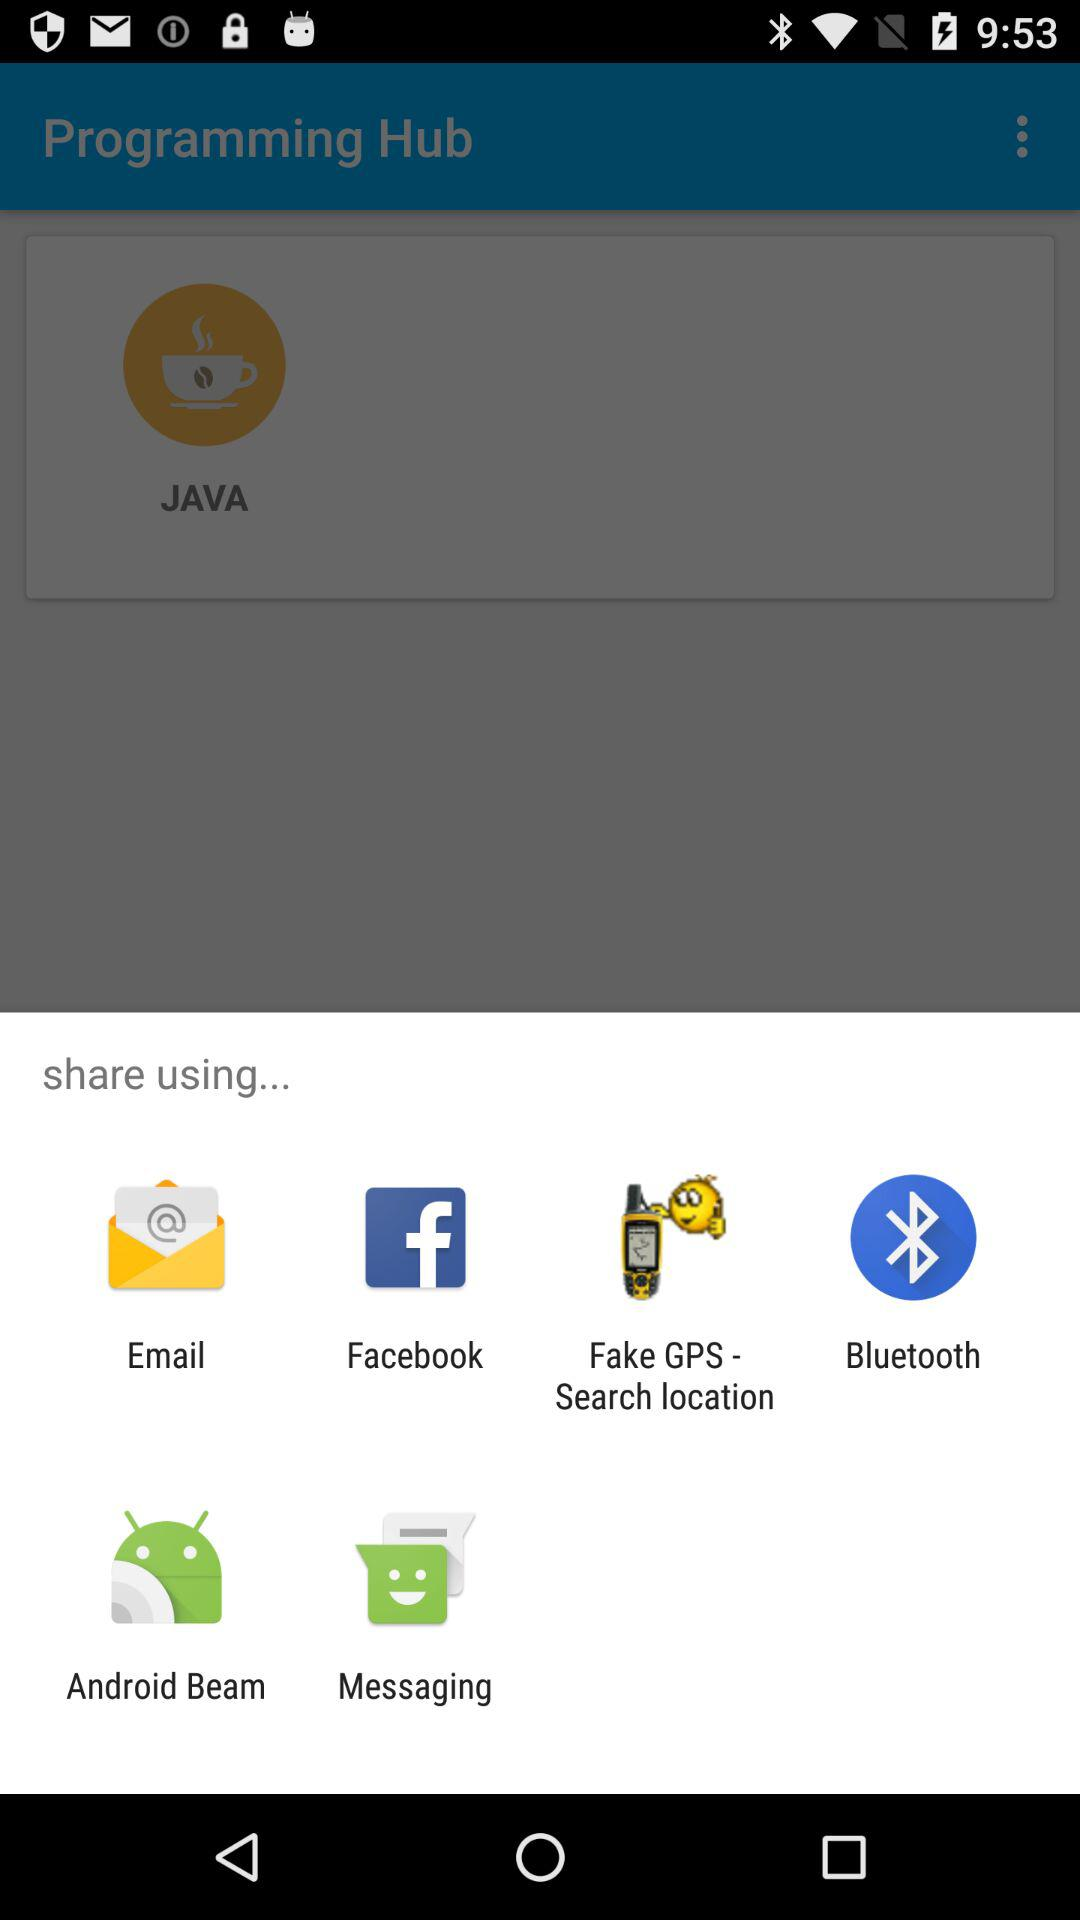Which applications are used to share? The applications used to share are : "Email", "Facebook", "Fake GPS - Search location", "Bluetooth", "Android Beam" and "Messaging". 